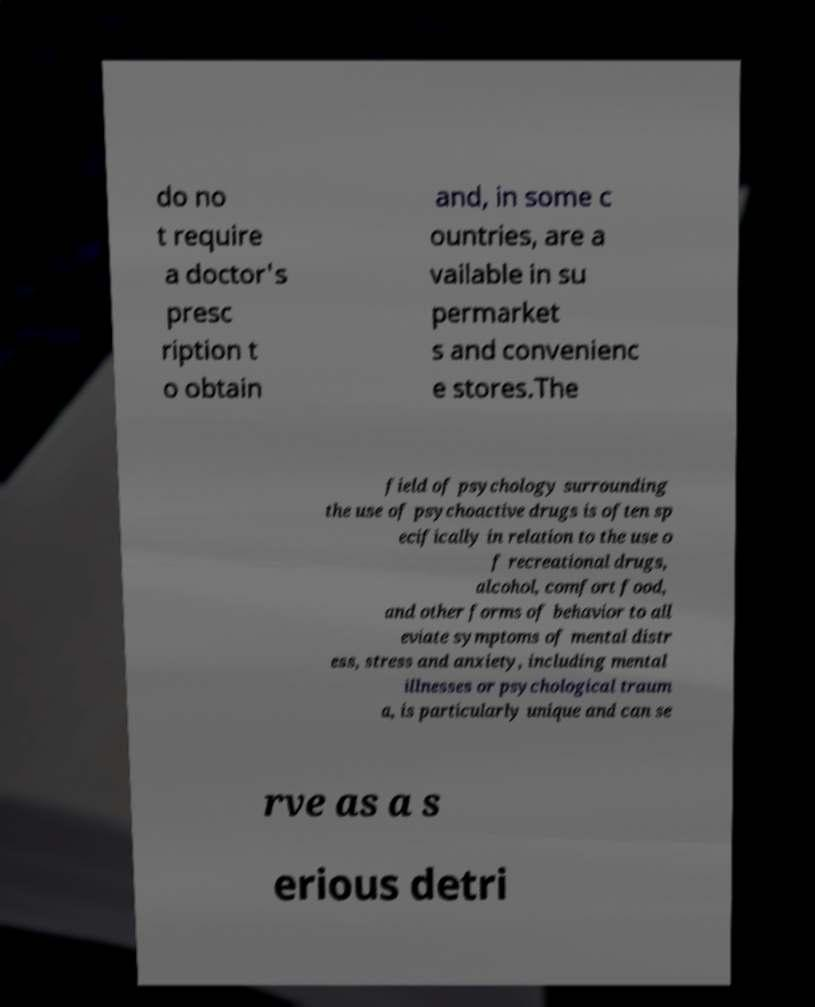I need the written content from this picture converted into text. Can you do that? do no t require a doctor's presc ription t o obtain and, in some c ountries, are a vailable in su permarket s and convenienc e stores.The field of psychology surrounding the use of psychoactive drugs is often sp ecifically in relation to the use o f recreational drugs, alcohol, comfort food, and other forms of behavior to all eviate symptoms of mental distr ess, stress and anxiety, including mental illnesses or psychological traum a, is particularly unique and can se rve as a s erious detri 